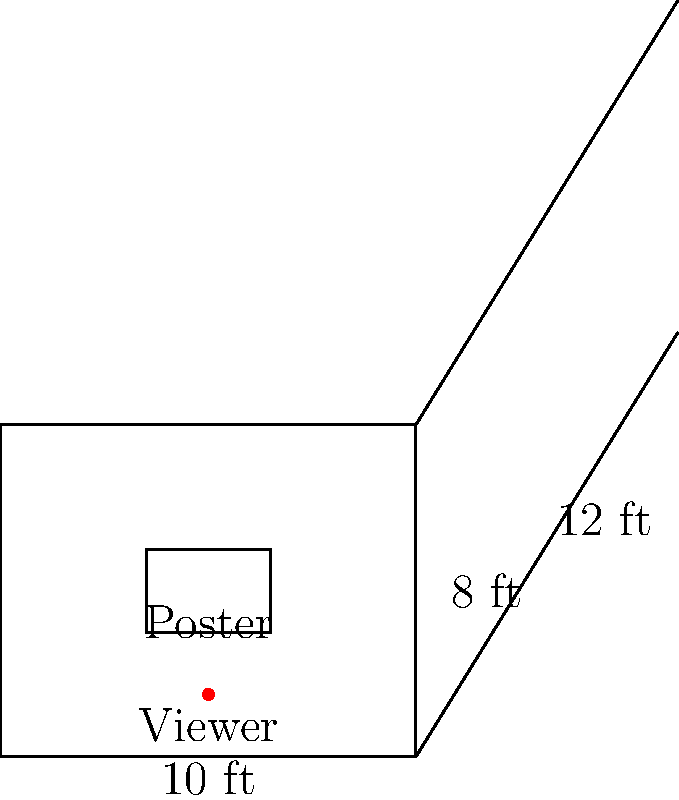In your bedroom, you've hung your favorite pop singer's poster (3 ft wide and 2 ft tall) at the center of a wall. The room is 10 ft wide, 8 ft high, and 12 ft deep. If you're standing 1.5 ft away from the wall with the poster, what is the optimal viewing angle (in degrees) to see the entire poster, and how far from the center of the wall should you stand for the best view? Let's approach this step-by-step:

1. First, we need to calculate the vertical viewing angle:
   - The poster is 2 ft tall, centered on an 8 ft wall
   - Your eyes are approximately 1.5 ft from the floor
   - Distance from eyes to poster center: $\frac{8}{2} - 1.5 = 2.5$ ft
   - Half of poster height: $\frac{2}{2} = 1$ ft
   - Vertical viewing angle: $\theta_v = 2 \cdot \arctan(\frac{1}{2.5}) \approx 43.6°$

2. Now, let's calculate the horizontal viewing angle:
   - The poster is 3 ft wide
   - You're standing 1.5 ft away from the wall
   - Half of poster width: $\frac{3}{2} = 1.5$ ft
   - Horizontal viewing angle: $\theta_h = 2 \cdot \arctan(\frac{1.5}{1.5}) = 90°$

3. The optimal viewing angle is the larger of these two angles: 90°

4. For the best view, you should stand where both angles are equal:
   - Let x be the distance from the wall
   - $\arctan(\frac{1.5}{x}) = \arctan(\frac{1}{2.5})$
   - Solving this equation: $x \approx 3.75$ ft

5. The distance from the center of the wall for the best view:
   - The room is 10 ft wide, so the center is at 5 ft
   - You should stand at $5 \pm \sqrt{3.75^2 - 1.5^2} \approx 5 \pm 3.43$ ft

Therefore, the optimal viewing angle is 90°, and you should stand about 3.43 ft to either side of the center of the wall, 3.75 ft away from the wall.
Answer: 90°; 3.43 ft from center 